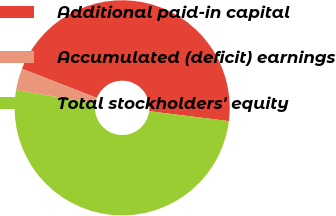Convert chart to OTSL. <chart><loc_0><loc_0><loc_500><loc_500><pie_chart><fcel>Additional paid-in capital<fcel>Accumulated (deficit) earnings<fcel>Total stockholders' equity<nl><fcel>46.05%<fcel>3.29%<fcel>50.66%<nl></chart> 